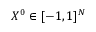Convert formula to latex. <formula><loc_0><loc_0><loc_500><loc_500>X ^ { 0 } \in [ - 1 , 1 ] ^ { N }</formula> 